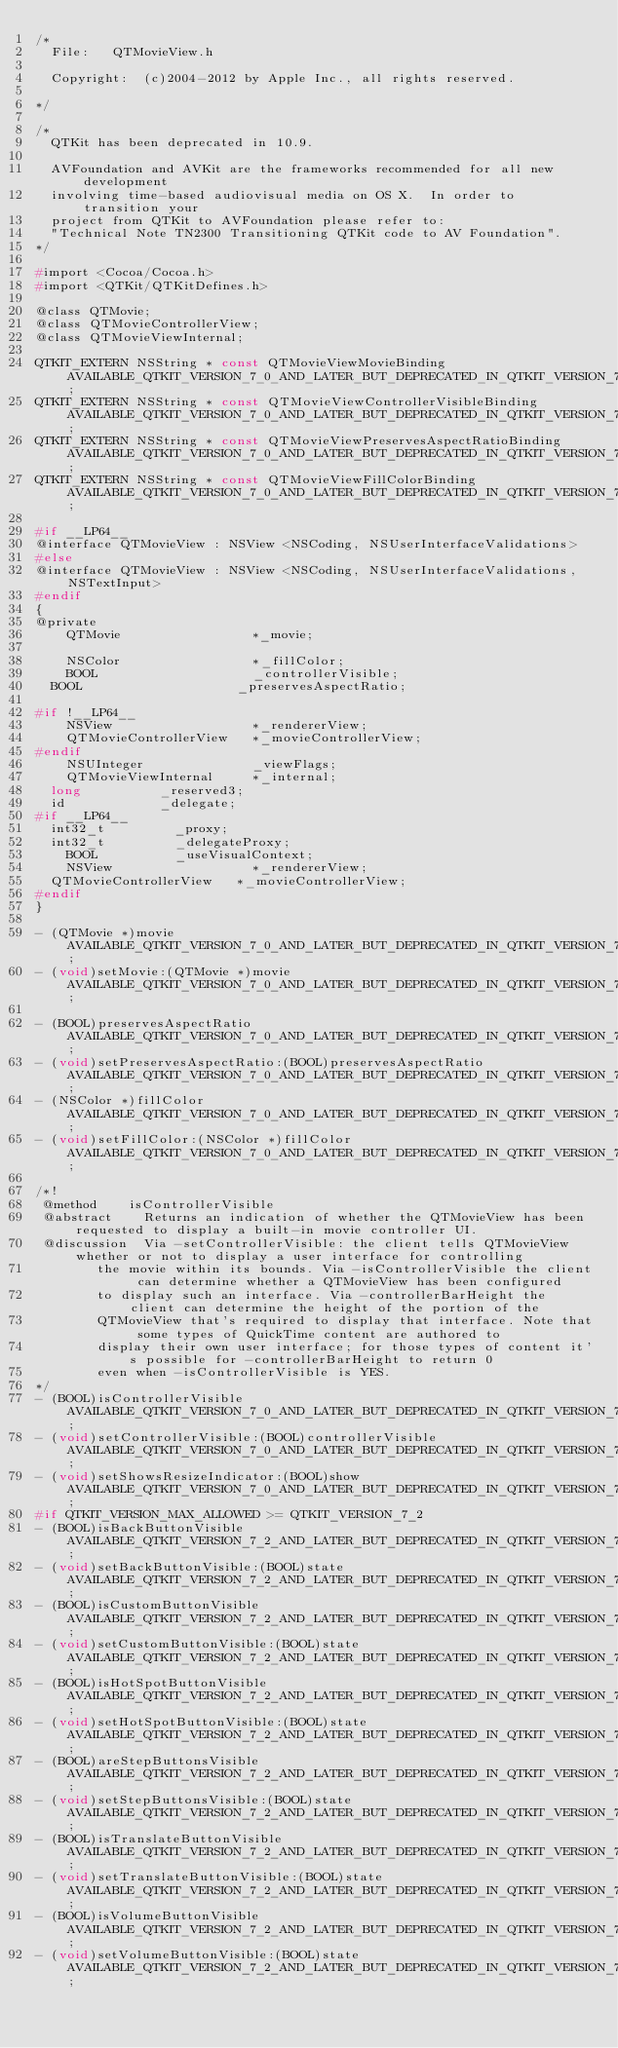<code> <loc_0><loc_0><loc_500><loc_500><_C_>/*
	File:		QTMovieView.h

	Copyright:	(c)2004-2012 by Apple Inc., all rights reserved.

*/

/*
  QTKit has been deprecated in 10.9.

  AVFoundation and AVKit are the frameworks recommended for all new development 
  involving time-based audiovisual media on OS X.  In order to transition your 
  project from QTKit to AVFoundation please refer to:
  "Technical Note TN2300 Transitioning QTKit code to AV Foundation".
*/

#import <Cocoa/Cocoa.h>
#import <QTKit/QTKitDefines.h>

@class QTMovie;
@class QTMovieControllerView;
@class QTMovieViewInternal;

QTKIT_EXTERN NSString * const QTMovieViewMovieBinding						AVAILABLE_QTKIT_VERSION_7_0_AND_LATER_BUT_DEPRECATED_IN_QTKIT_VERSION_7_7_3;
QTKIT_EXTERN NSString * const QTMovieViewControllerVisibleBinding			AVAILABLE_QTKIT_VERSION_7_0_AND_LATER_BUT_DEPRECATED_IN_QTKIT_VERSION_7_7_3;
QTKIT_EXTERN NSString * const QTMovieViewPreservesAspectRatioBinding		AVAILABLE_QTKIT_VERSION_7_0_AND_LATER_BUT_DEPRECATED_IN_QTKIT_VERSION_7_7_3;
QTKIT_EXTERN NSString * const QTMovieViewFillColorBinding					AVAILABLE_QTKIT_VERSION_7_0_AND_LATER_BUT_DEPRECATED_IN_QTKIT_VERSION_7_7_3;

#if __LP64__
@interface QTMovieView : NSView <NSCoding, NSUserInterfaceValidations>
#else
@interface QTMovieView : NSView <NSCoding, NSUserInterfaceValidations, NSTextInput>
#endif
{
@private
    QTMovie                 *_movie;
    
    NSColor                 *_fillColor;
    BOOL                    _controllerVisible;
	BOOL                    _preservesAspectRatio;
    
#if !__LP64__
    NSView                  *_rendererView;
    QTMovieControllerView   *_movieControllerView;
#endif    
    NSUInteger              _viewFlags;
    QTMovieViewInternal     *_internal;
	long					_reserved3;
	id						_delegate;
#if __LP64__
	int32_t					_proxy;
	int32_t					_delegateProxy;
    BOOL					_useVisualContext;
    NSView                  *_rendererView;
	QTMovieControllerView   *_movieControllerView;
#endif
}

- (QTMovie *)movie AVAILABLE_QTKIT_VERSION_7_0_AND_LATER_BUT_DEPRECATED_IN_QTKIT_VERSION_7_7_3;
- (void)setMovie:(QTMovie *)movie AVAILABLE_QTKIT_VERSION_7_0_AND_LATER_BUT_DEPRECATED_IN_QTKIT_VERSION_7_7_3;

- (BOOL)preservesAspectRatio AVAILABLE_QTKIT_VERSION_7_0_AND_LATER_BUT_DEPRECATED_IN_QTKIT_VERSION_7_7_3;
- (void)setPreservesAspectRatio:(BOOL)preservesAspectRatio AVAILABLE_QTKIT_VERSION_7_0_AND_LATER_BUT_DEPRECATED_IN_QTKIT_VERSION_7_7_3;
- (NSColor *)fillColor AVAILABLE_QTKIT_VERSION_7_0_AND_LATER_BUT_DEPRECATED_IN_QTKIT_VERSION_7_7_3;
- (void)setFillColor:(NSColor *)fillColor AVAILABLE_QTKIT_VERSION_7_0_AND_LATER_BUT_DEPRECATED_IN_QTKIT_VERSION_7_7_3;

/*!
 @method		isControllerVisible
 @abstract		Returns an indication of whether the QTMovieView has been requested to display a built-in movie controller UI.
 @discussion	Via -setControllerVisible: the client tells QTMovieView whether or not to display a user interface for controlling
 				the movie within its bounds. Via -isControllerVisible the client can determine whether a QTMovieView has been configured
 				to display such an interface. Via -controllerBarHeight the client can determine the height of the portion of the
 				QTMovieView that's required to display that interface. Note that some types of QuickTime content are authored to
 				display their own user interface; for those types of content it's possible for -controllerBarHeight to return 0
 				even when -isControllerVisible is YES.
*/
- (BOOL)isControllerVisible AVAILABLE_QTKIT_VERSION_7_0_AND_LATER_BUT_DEPRECATED_IN_QTKIT_VERSION_7_7_3;
- (void)setControllerVisible:(BOOL)controllerVisible AVAILABLE_QTKIT_VERSION_7_0_AND_LATER_BUT_DEPRECATED_IN_QTKIT_VERSION_7_7_3;
- (void)setShowsResizeIndicator:(BOOL)show AVAILABLE_QTKIT_VERSION_7_0_AND_LATER_BUT_DEPRECATED_IN_QTKIT_VERSION_7_7_3;
#if QTKIT_VERSION_MAX_ALLOWED >= QTKIT_VERSION_7_2
- (BOOL)isBackButtonVisible AVAILABLE_QTKIT_VERSION_7_2_AND_LATER_BUT_DEPRECATED_IN_QTKIT_VERSION_7_7_3;
- (void)setBackButtonVisible:(BOOL)state AVAILABLE_QTKIT_VERSION_7_2_AND_LATER_BUT_DEPRECATED_IN_QTKIT_VERSION_7_7_3;
- (BOOL)isCustomButtonVisible AVAILABLE_QTKIT_VERSION_7_2_AND_LATER_BUT_DEPRECATED_IN_QTKIT_VERSION_7_7_3;
- (void)setCustomButtonVisible:(BOOL)state AVAILABLE_QTKIT_VERSION_7_2_AND_LATER_BUT_DEPRECATED_IN_QTKIT_VERSION_7_7_3;
- (BOOL)isHotSpotButtonVisible AVAILABLE_QTKIT_VERSION_7_2_AND_LATER_BUT_DEPRECATED_IN_QTKIT_VERSION_7_7_3;
- (void)setHotSpotButtonVisible:(BOOL)state AVAILABLE_QTKIT_VERSION_7_2_AND_LATER_BUT_DEPRECATED_IN_QTKIT_VERSION_7_7_3;
- (BOOL)areStepButtonsVisible AVAILABLE_QTKIT_VERSION_7_2_AND_LATER_BUT_DEPRECATED_IN_QTKIT_VERSION_7_7_3;
- (void)setStepButtonsVisible:(BOOL)state AVAILABLE_QTKIT_VERSION_7_2_AND_LATER_BUT_DEPRECATED_IN_QTKIT_VERSION_7_7_3;
- (BOOL)isTranslateButtonVisible AVAILABLE_QTKIT_VERSION_7_2_AND_LATER_BUT_DEPRECATED_IN_QTKIT_VERSION_7_7_3;
- (void)setTranslateButtonVisible:(BOOL)state AVAILABLE_QTKIT_VERSION_7_2_AND_LATER_BUT_DEPRECATED_IN_QTKIT_VERSION_7_7_3;
- (BOOL)isVolumeButtonVisible AVAILABLE_QTKIT_VERSION_7_2_AND_LATER_BUT_DEPRECATED_IN_QTKIT_VERSION_7_7_3;
- (void)setVolumeButtonVisible:(BOOL)state AVAILABLE_QTKIT_VERSION_7_2_AND_LATER_BUT_DEPRECATED_IN_QTKIT_VERSION_7_7_3;</code> 